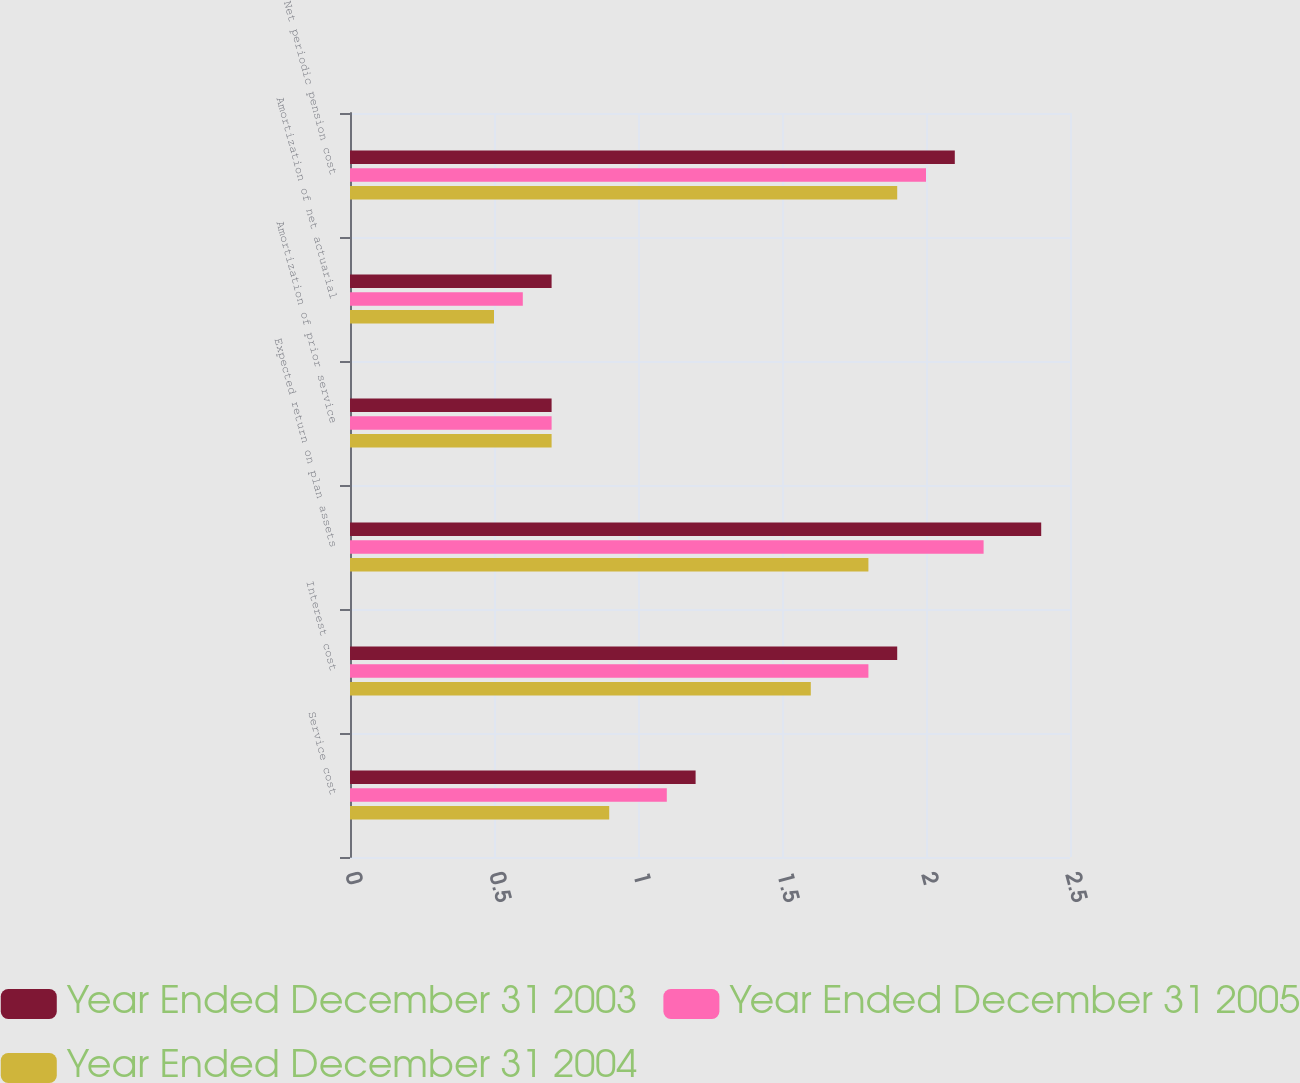Convert chart. <chart><loc_0><loc_0><loc_500><loc_500><stacked_bar_chart><ecel><fcel>Service cost<fcel>Interest cost<fcel>Expected return on plan assets<fcel>Amortization of prior service<fcel>Amortization of net actuarial<fcel>Net periodic pension cost<nl><fcel>Year Ended December 31 2003<fcel>1.2<fcel>1.9<fcel>2.4<fcel>0.7<fcel>0.7<fcel>2.1<nl><fcel>Year Ended December 31 2005<fcel>1.1<fcel>1.8<fcel>2.2<fcel>0.7<fcel>0.6<fcel>2<nl><fcel>Year Ended December 31 2004<fcel>0.9<fcel>1.6<fcel>1.8<fcel>0.7<fcel>0.5<fcel>1.9<nl></chart> 